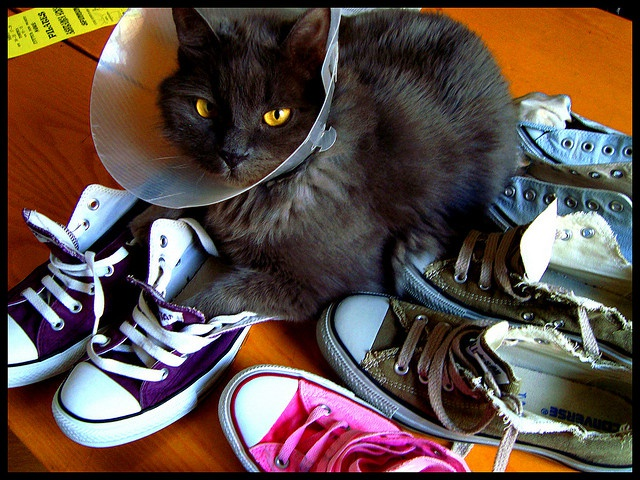Describe the objects in this image and their specific colors. I can see a cat in black and gray tones in this image. 